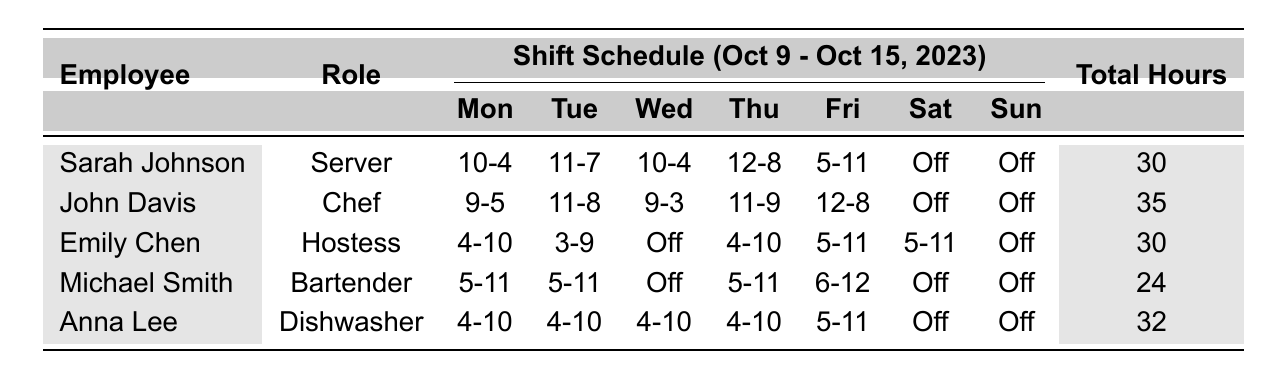What is the total number of hours worked by Sarah Johnson? Sarah Johnson is listed under the "Total Hours" column with a value of 30.
Answer: 30 Which employee has the highest total hours worked? By comparing the "Total Hours" column, John Davis has 35 hours, which is the highest among all employees.
Answer: John Davis How many days did Michael Smith work during the week? Michael Smith’s shifts are listed as working on Monday, Tuesday, Thursday, and Friday, totaling 4 days.
Answer: 4 What is the total number of hours worked by Emily Chen and Anna Lee combined? Emily Chen worked 30 hours, and Anna Lee worked 32 hours. Adding these gives 30 + 32 = 62 hours.
Answer: 62 Did any employee have shifts on both Saturday and Sunday? Referring to the shifts, all employees have "Off" listed for both Saturday and Sunday, so the answer is no.
Answer: No What is the average number of hours worked by all employees? The total hours for all employees is 30 + 35 + 30 + 24 + 32 = 151. There are 5 employees, so the average is 151/5 = 30.2.
Answer: 30.2 How many hours did Anna Lee work compared to Sarah Johnson? Anna Lee worked 32 hours and Sarah Johnson worked 30 hours. Subtracting gives 32 - 30 = 2, so Anna Lee worked 2 hours more.
Answer: 2 hours more Which role has the least total hours worked this week? Reviewing the total hours, Michael Smith as a Bartender has the least at 24 hours.
Answer: Bartender Did John Davis work more hours than Emily Chen? John Davis worked 35 hours, while Emily Chen worked 30 hours. Since 35 is greater than 30, the answer is yes.
Answer: Yes Which employee worked the least number of days this week? By comparing the number of days worked, Michael Smith worked on 4 days while all others worked at least 5 days, so Michael Smith worked the least.
Answer: Michael Smith 